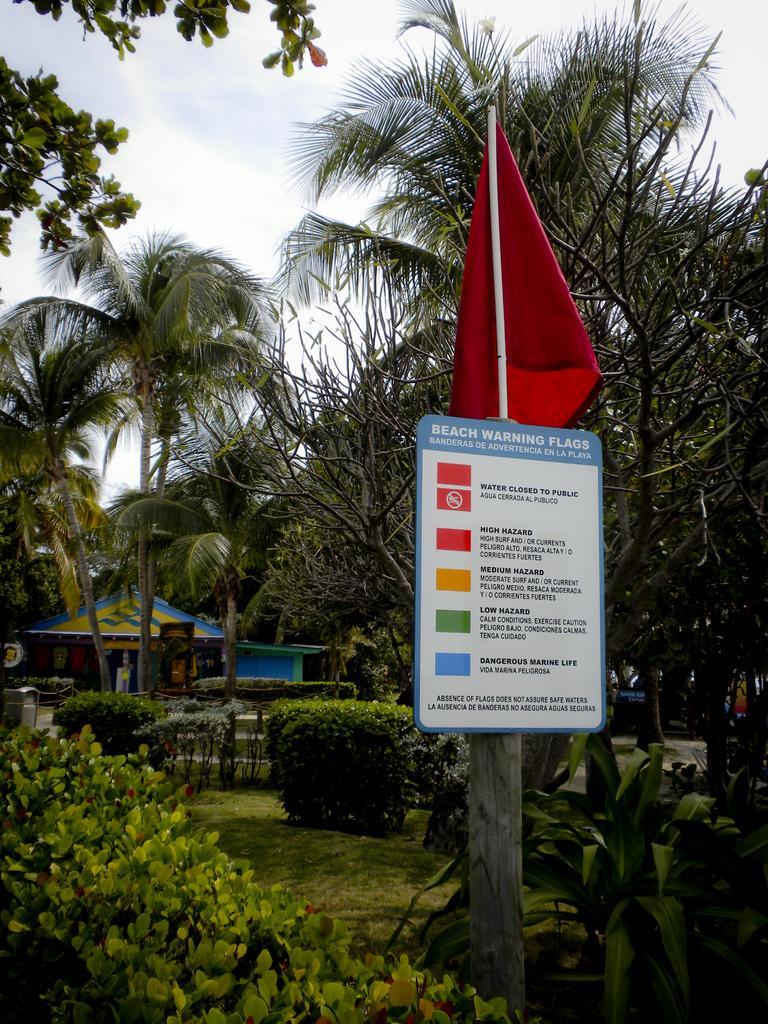Could you give a brief overview of what you see in this image? In this image we can see a board with some text on it. We can also see a wooden pole, the flag, planted, grass, a group of trees, a house and the sky. 